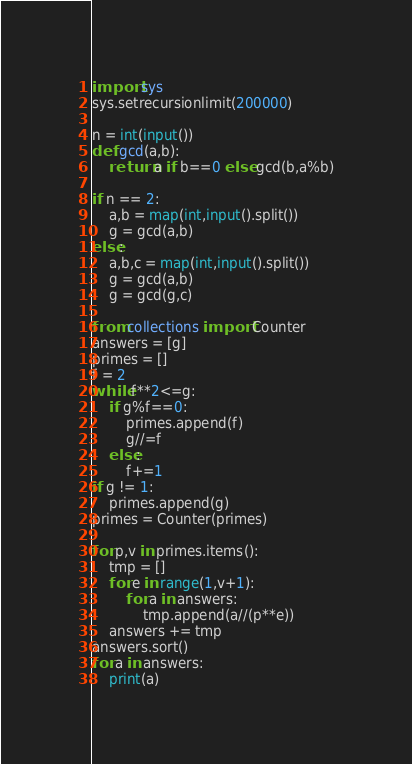<code> <loc_0><loc_0><loc_500><loc_500><_Python_>import sys
sys.setrecursionlimit(200000)

n = int(input())
def gcd(a,b):
    return a if b==0 else gcd(b,a%b)

if n == 2:
    a,b = map(int,input().split())
    g = gcd(a,b)
else:
    a,b,c = map(int,input().split())
    g = gcd(a,b)
    g = gcd(g,c)

from collections import Counter
answers = [g]
primes = []
f = 2
while f**2<=g:
    if g%f==0:
        primes.append(f)
        g//=f
    else:
        f+=1
if g != 1:
    primes.append(g)
primes = Counter(primes)

for p,v in primes.items():
    tmp = []
    for e in range(1,v+1):
        for a in answers:
            tmp.append(a//(p**e))
    answers += tmp
answers.sort()
for a in answers:
    print(a)
</code> 